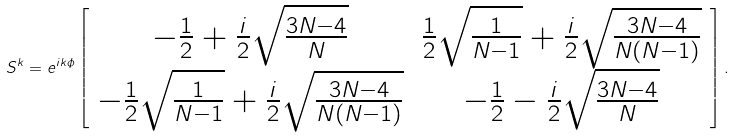<formula> <loc_0><loc_0><loc_500><loc_500>S ^ { k } = e ^ { i k \phi } \left [ \begin{array} { c c } - \frac { 1 } { 2 } + \frac { i } { 2 } \sqrt { \frac { 3 N - 4 } { N } } & \frac { 1 } { 2 } \sqrt { \frac { 1 } { N - 1 } } + \frac { i } { 2 } \sqrt { \frac { 3 N - 4 } { N ( N - 1 ) } } \\ - \frac { 1 } { 2 } \sqrt { \frac { 1 } { N - 1 } } + \frac { i } { 2 } \sqrt { \frac { 3 N - 4 } { N ( N - 1 ) } } & - \frac { 1 } { 2 } - \frac { i } { 2 } \sqrt { \frac { 3 N - 4 } { N } } \end{array} \right ] .</formula> 